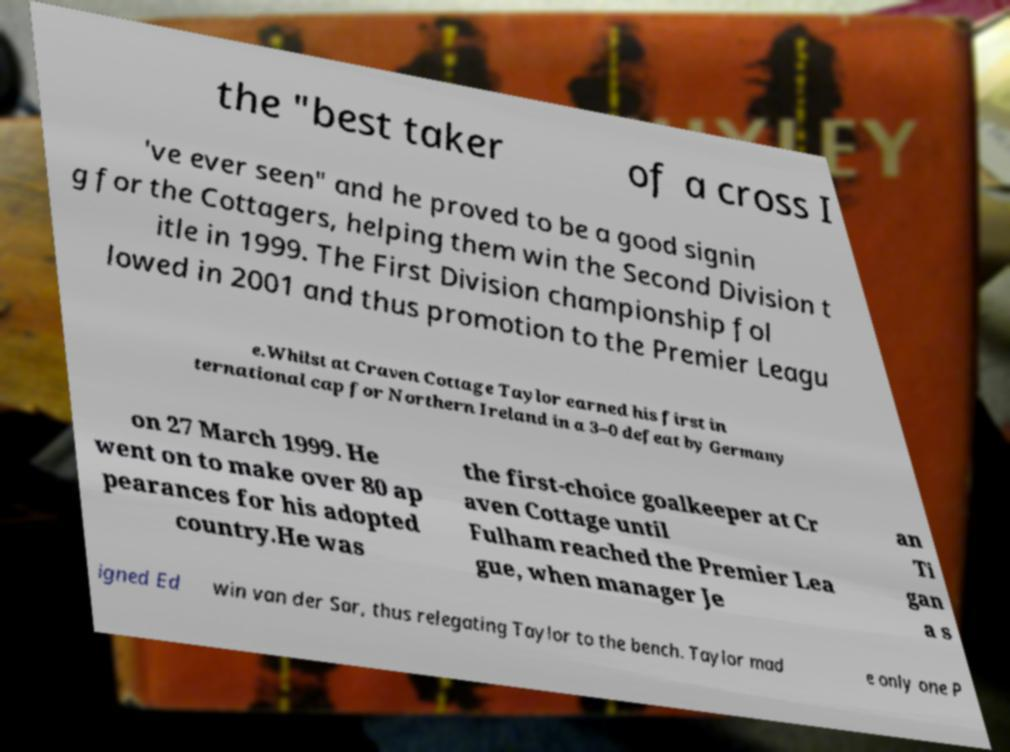There's text embedded in this image that I need extracted. Can you transcribe it verbatim? the "best taker of a cross I 've ever seen" and he proved to be a good signin g for the Cottagers, helping them win the Second Division t itle in 1999. The First Division championship fol lowed in 2001 and thus promotion to the Premier Leagu e.Whilst at Craven Cottage Taylor earned his first in ternational cap for Northern Ireland in a 3–0 defeat by Germany on 27 March 1999. He went on to make over 80 ap pearances for his adopted country.He was the first-choice goalkeeper at Cr aven Cottage until Fulham reached the Premier Lea gue, when manager Je an Ti gan a s igned Ed win van der Sar, thus relegating Taylor to the bench. Taylor mad e only one P 